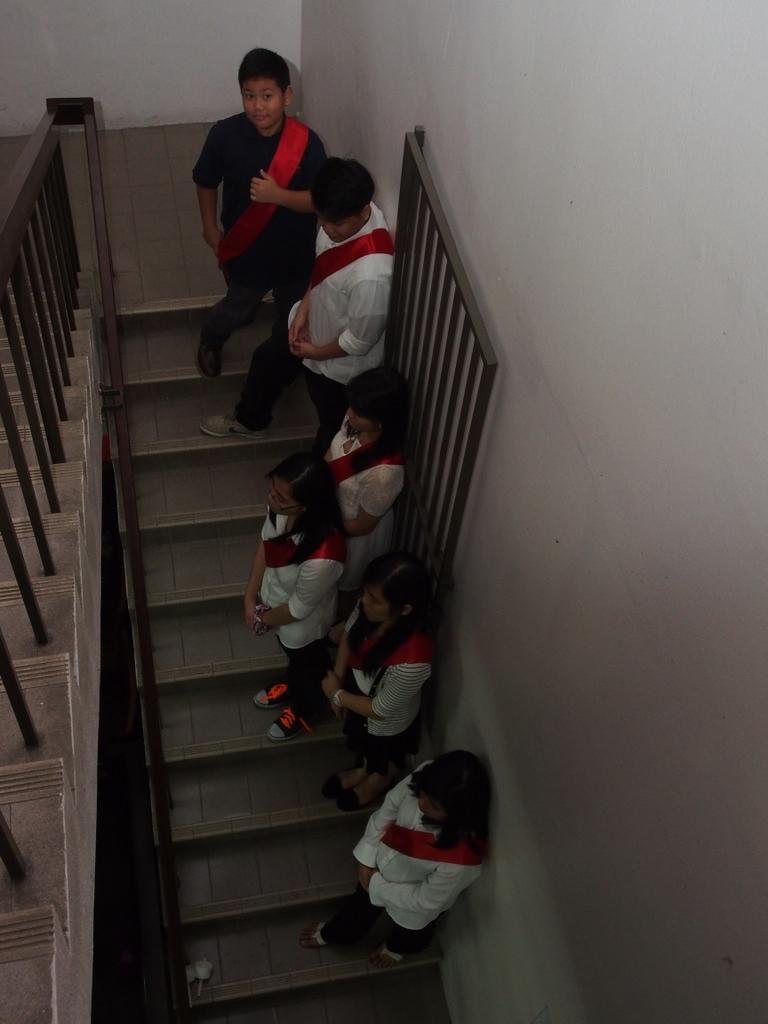What is the main subject of the image? The main subject of the image is a group of people. Where are the people located in the image? The people are standing on a staircase. What are the people holding in the image? The people are carrying bags. What can be seen on the left side of the image? There is a railing on the left side of the image. Can you see any toads jumping around the people in the image? There are no toads present in the image. What type of wave is visible in the background of the image? There is no wave visible in the image, as it features a group of people standing on a staircase. 